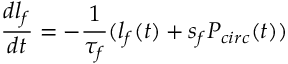Convert formula to latex. <formula><loc_0><loc_0><loc_500><loc_500>\frac { d l _ { f } } { d t } = - \frac { 1 } { \tau _ { f } } ( l _ { f } ( t ) + s _ { f } P _ { c i r c } ( t ) )</formula> 